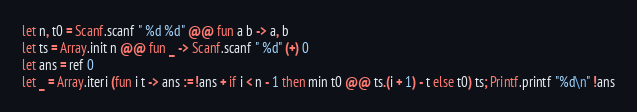<code> <loc_0><loc_0><loc_500><loc_500><_OCaml_>let n, t0 = Scanf.scanf " %d %d" @@ fun a b -> a, b
let ts = Array.init n @@ fun _ -> Scanf.scanf " %d" (+) 0
let ans = ref 0
let _ = Array.iteri (fun i t -> ans := !ans + if i < n - 1 then min t0 @@ ts.(i + 1) - t else t0) ts; Printf.printf "%d\n" !ans</code> 